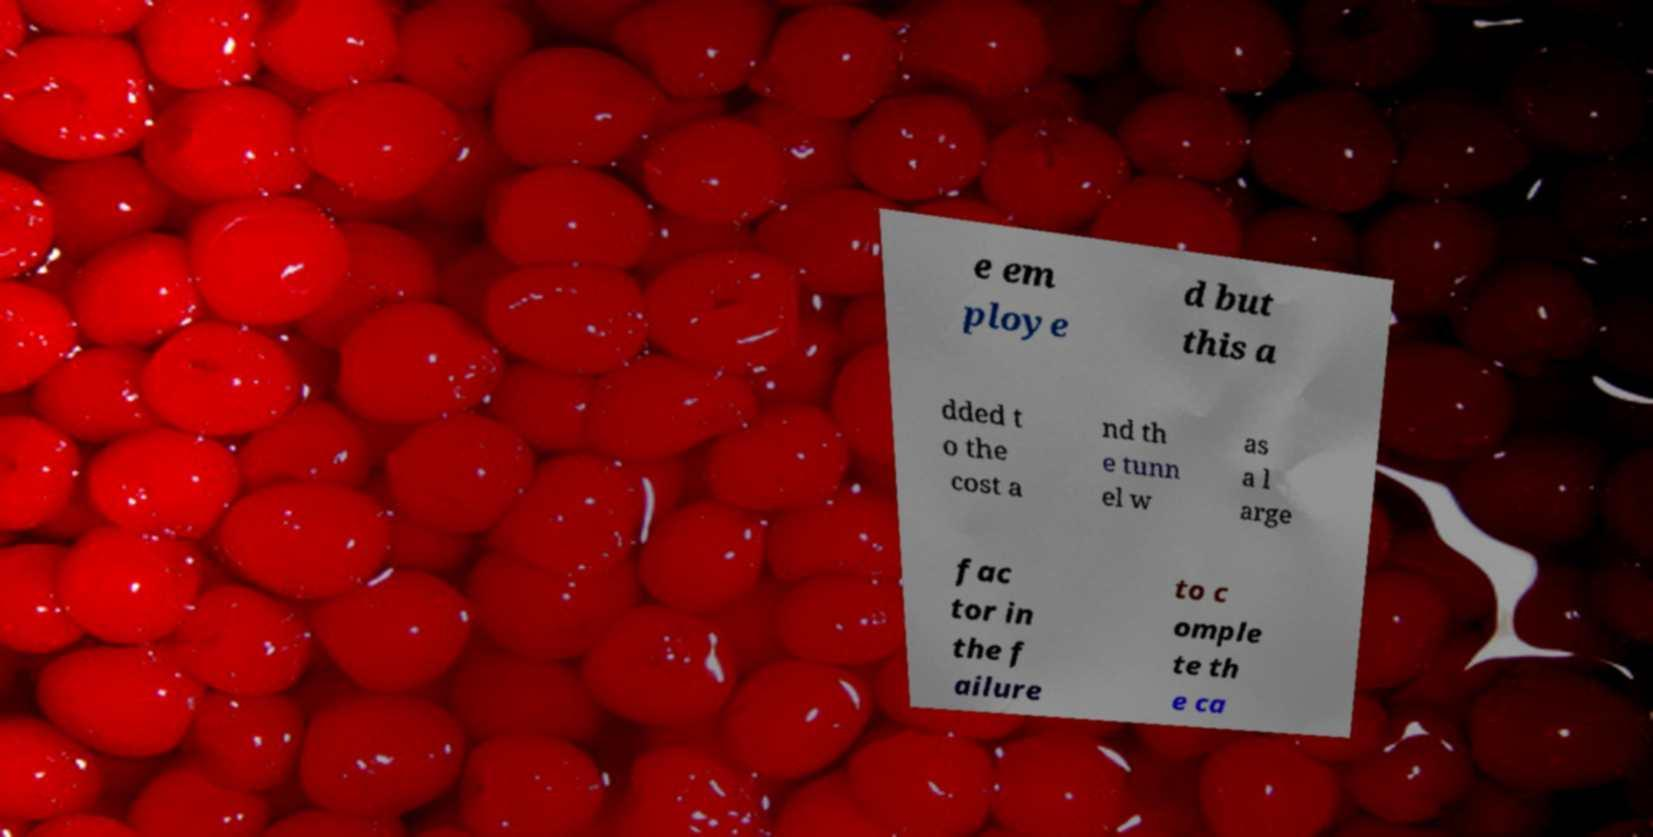What messages or text are displayed in this image? I need them in a readable, typed format. e em ploye d but this a dded t o the cost a nd th e tunn el w as a l arge fac tor in the f ailure to c omple te th e ca 